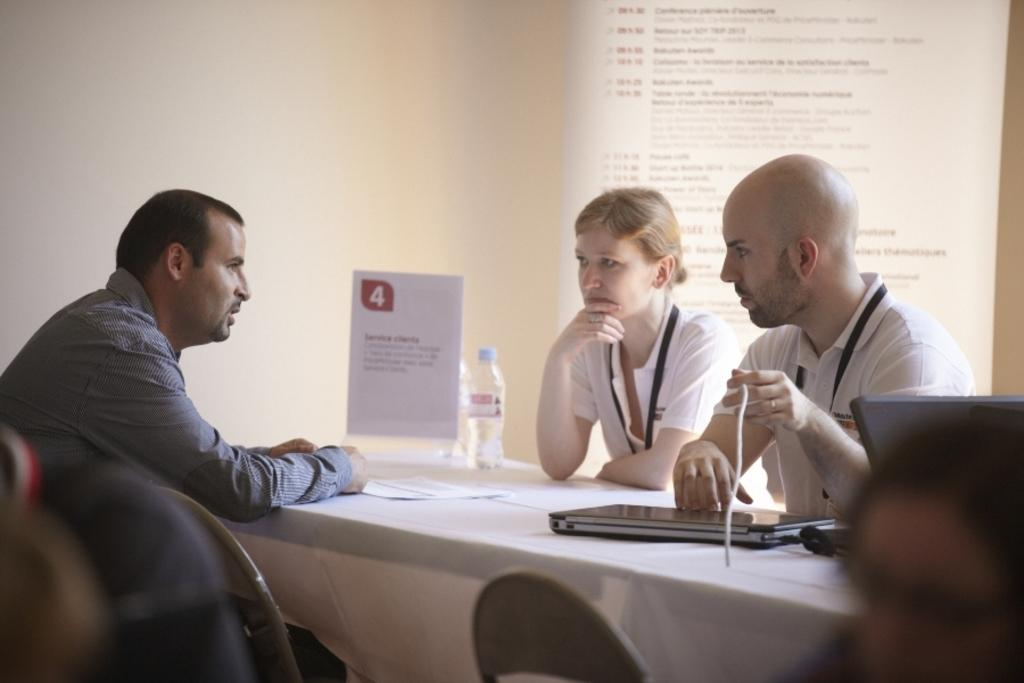What are the people in the image doing? The people in the image are sitting on chairs. What can be seen on the table in the image? There is a laptop, a water bottle, and a menu card on the table. What is on the wall in the background of the image? There is a projector screen on the wall in the background. How many kittens are crawling on the laptop in the image? There are no kittens present in the image; the laptop is not being used by any animals. 